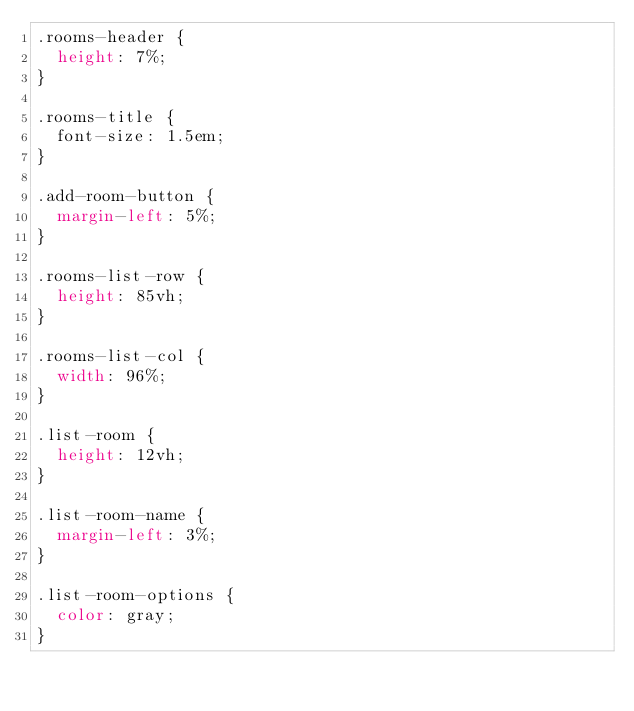Convert code to text. <code><loc_0><loc_0><loc_500><loc_500><_CSS_>.rooms-header {
  height: 7%;
}

.rooms-title {
  font-size: 1.5em;
}

.add-room-button {
  margin-left: 5%;
}

.rooms-list-row {
  height: 85vh;
}

.rooms-list-col {
  width: 96%;
}

.list-room {
  height: 12vh;
}

.list-room-name {
  margin-left: 3%;
}

.list-room-options {
  color: gray;
}</code> 